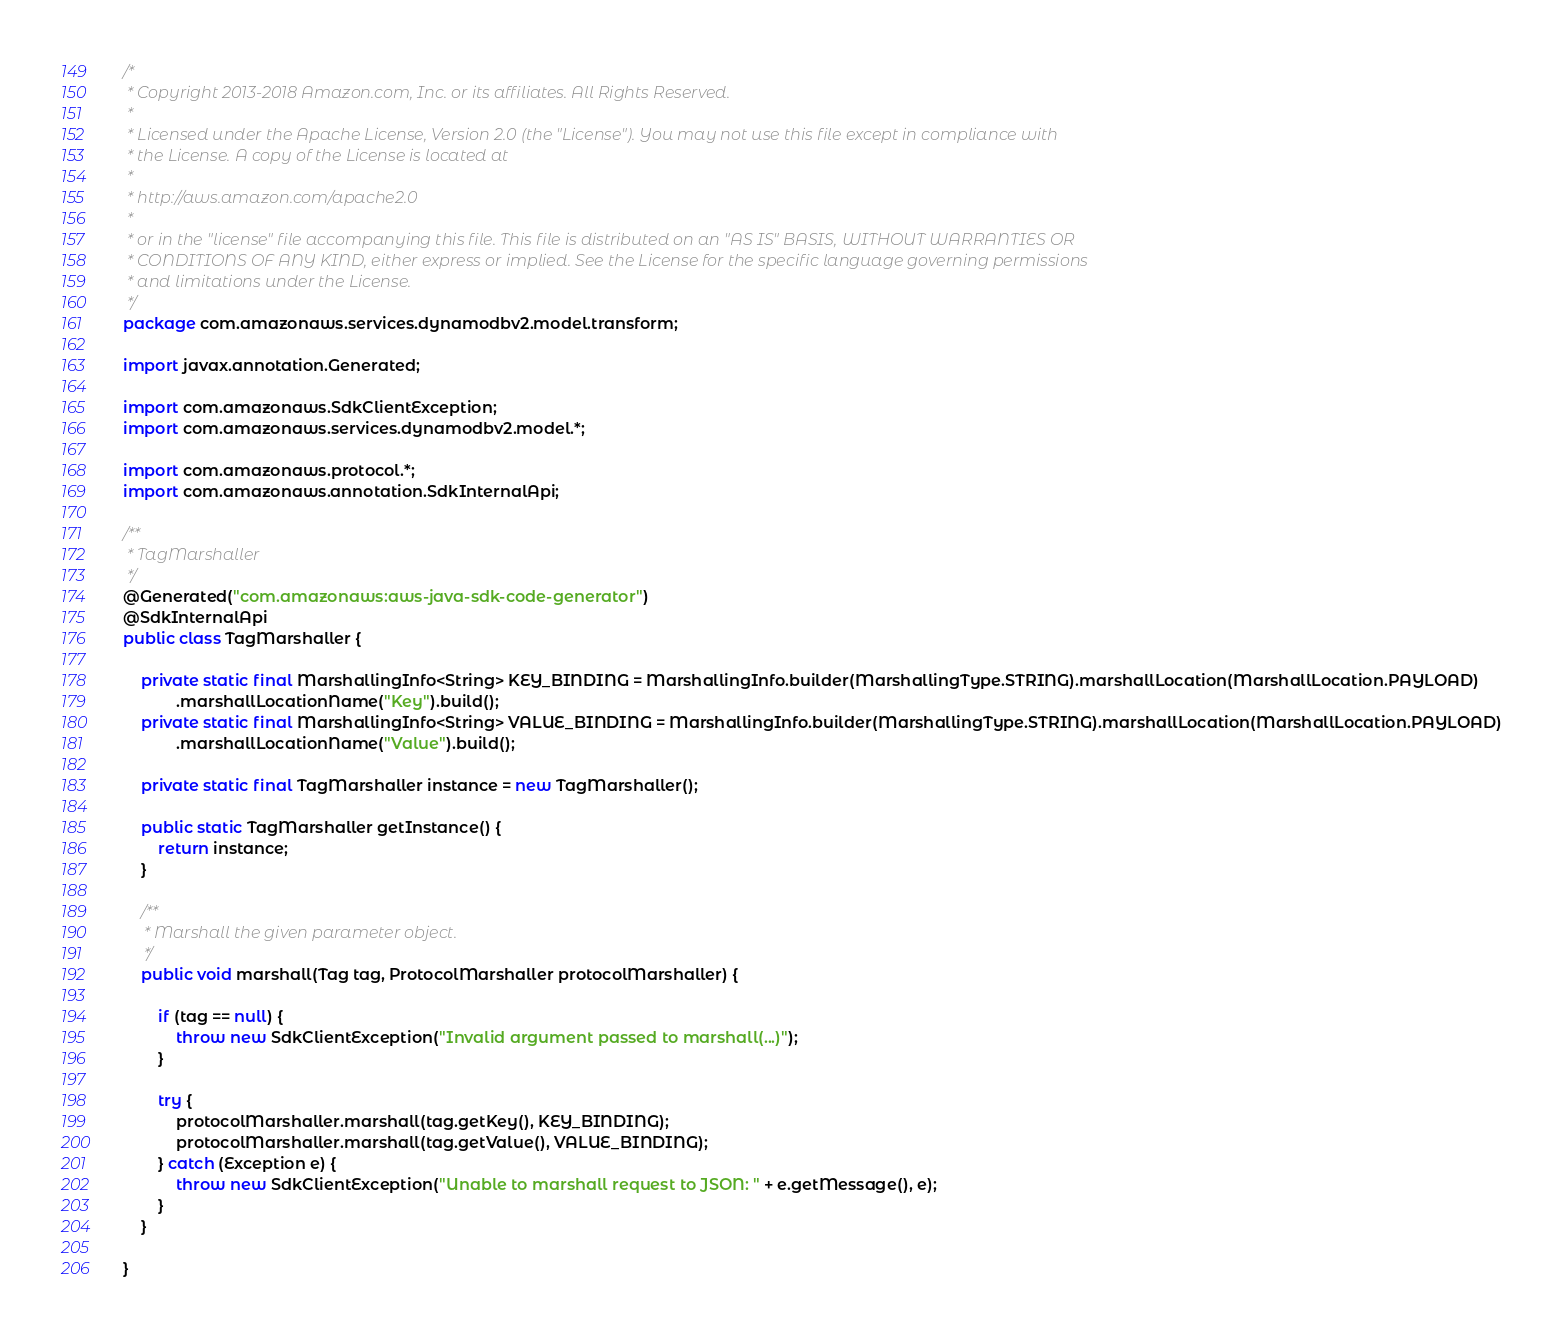Convert code to text. <code><loc_0><loc_0><loc_500><loc_500><_Java_>/*
 * Copyright 2013-2018 Amazon.com, Inc. or its affiliates. All Rights Reserved.
 * 
 * Licensed under the Apache License, Version 2.0 (the "License"). You may not use this file except in compliance with
 * the License. A copy of the License is located at
 * 
 * http://aws.amazon.com/apache2.0
 * 
 * or in the "license" file accompanying this file. This file is distributed on an "AS IS" BASIS, WITHOUT WARRANTIES OR
 * CONDITIONS OF ANY KIND, either express or implied. See the License for the specific language governing permissions
 * and limitations under the License.
 */
package com.amazonaws.services.dynamodbv2.model.transform;

import javax.annotation.Generated;

import com.amazonaws.SdkClientException;
import com.amazonaws.services.dynamodbv2.model.*;

import com.amazonaws.protocol.*;
import com.amazonaws.annotation.SdkInternalApi;

/**
 * TagMarshaller
 */
@Generated("com.amazonaws:aws-java-sdk-code-generator")
@SdkInternalApi
public class TagMarshaller {

    private static final MarshallingInfo<String> KEY_BINDING = MarshallingInfo.builder(MarshallingType.STRING).marshallLocation(MarshallLocation.PAYLOAD)
            .marshallLocationName("Key").build();
    private static final MarshallingInfo<String> VALUE_BINDING = MarshallingInfo.builder(MarshallingType.STRING).marshallLocation(MarshallLocation.PAYLOAD)
            .marshallLocationName("Value").build();

    private static final TagMarshaller instance = new TagMarshaller();

    public static TagMarshaller getInstance() {
        return instance;
    }

    /**
     * Marshall the given parameter object.
     */
    public void marshall(Tag tag, ProtocolMarshaller protocolMarshaller) {

        if (tag == null) {
            throw new SdkClientException("Invalid argument passed to marshall(...)");
        }

        try {
            protocolMarshaller.marshall(tag.getKey(), KEY_BINDING);
            protocolMarshaller.marshall(tag.getValue(), VALUE_BINDING);
        } catch (Exception e) {
            throw new SdkClientException("Unable to marshall request to JSON: " + e.getMessage(), e);
        }
    }

}
</code> 